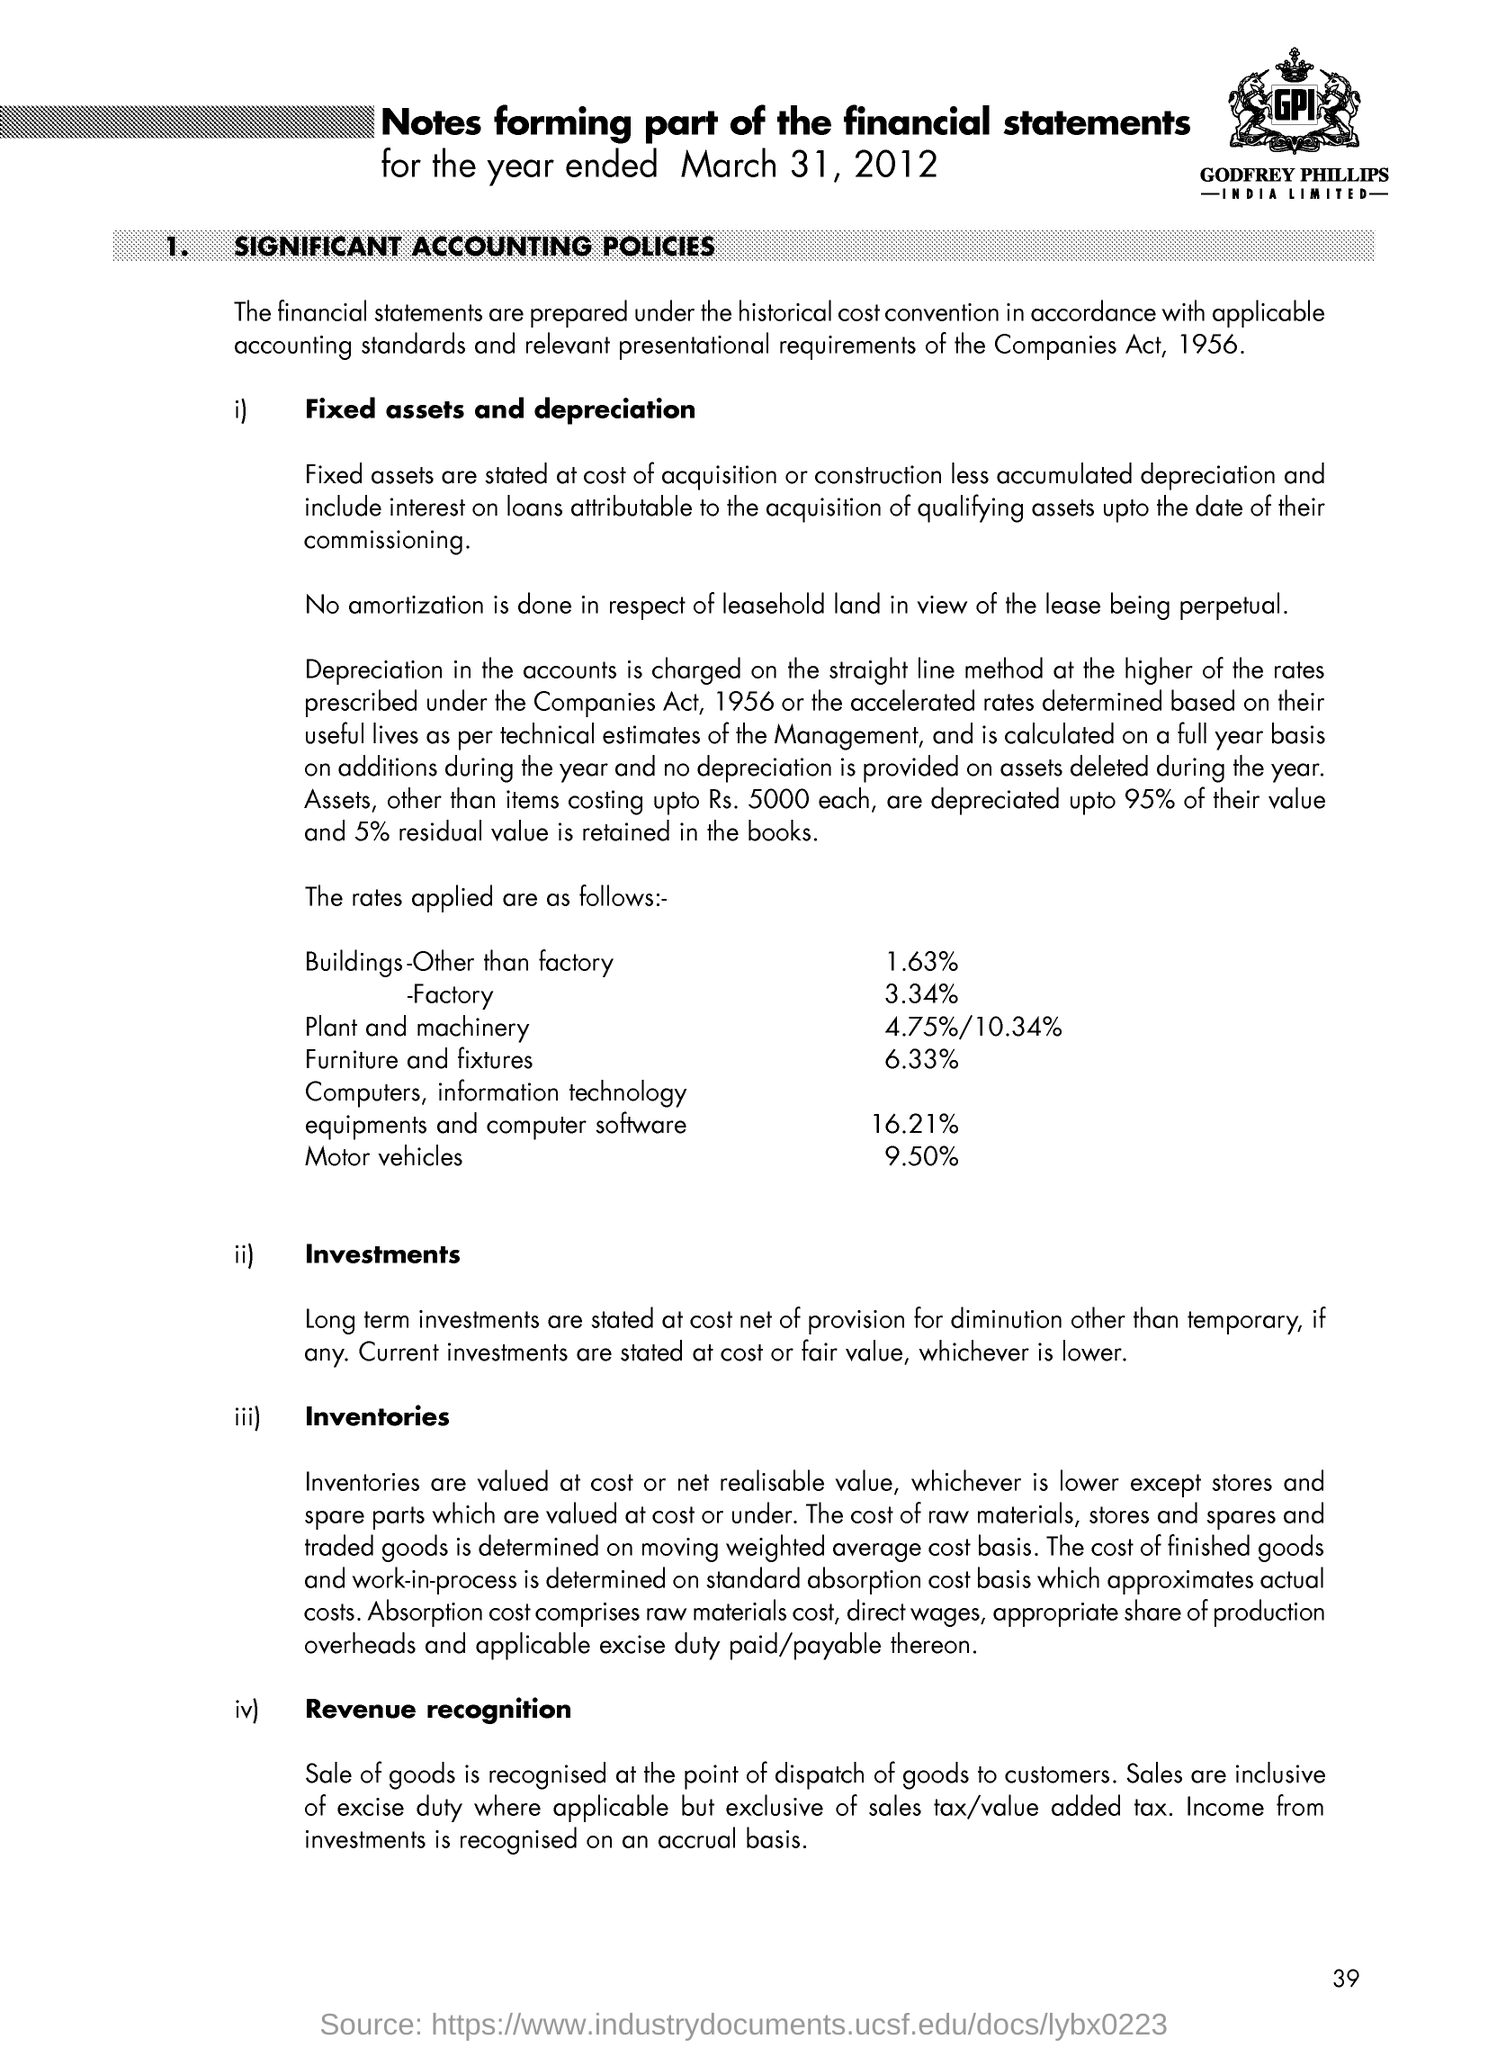Mention a couple of crucial points in this snapshot. Depreciation is charged using the straight line method in accounts. 